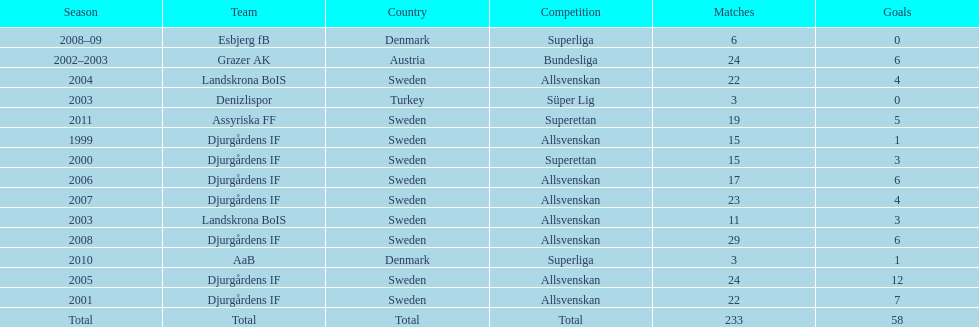What was the number of goals he scored in 2005? 12. 